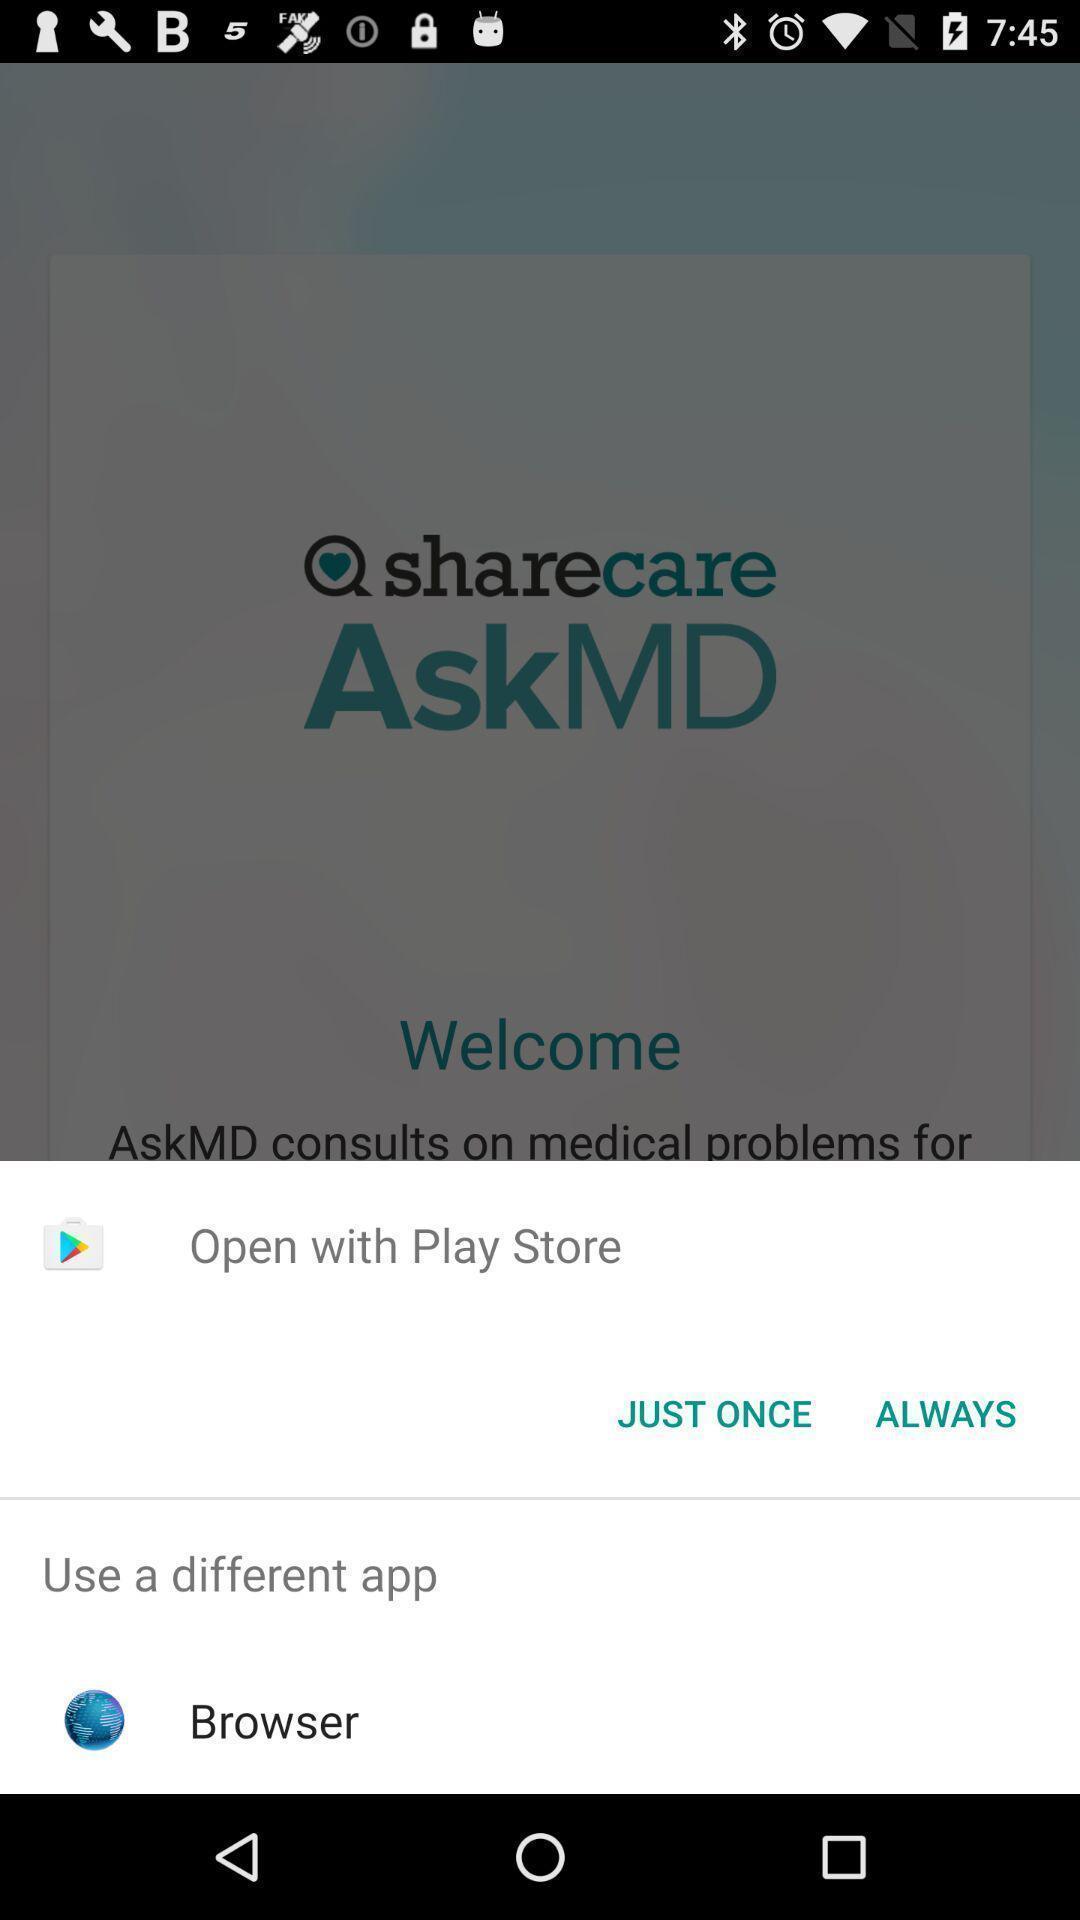Summarize the main components in this picture. Pop-up with options to open a link. 